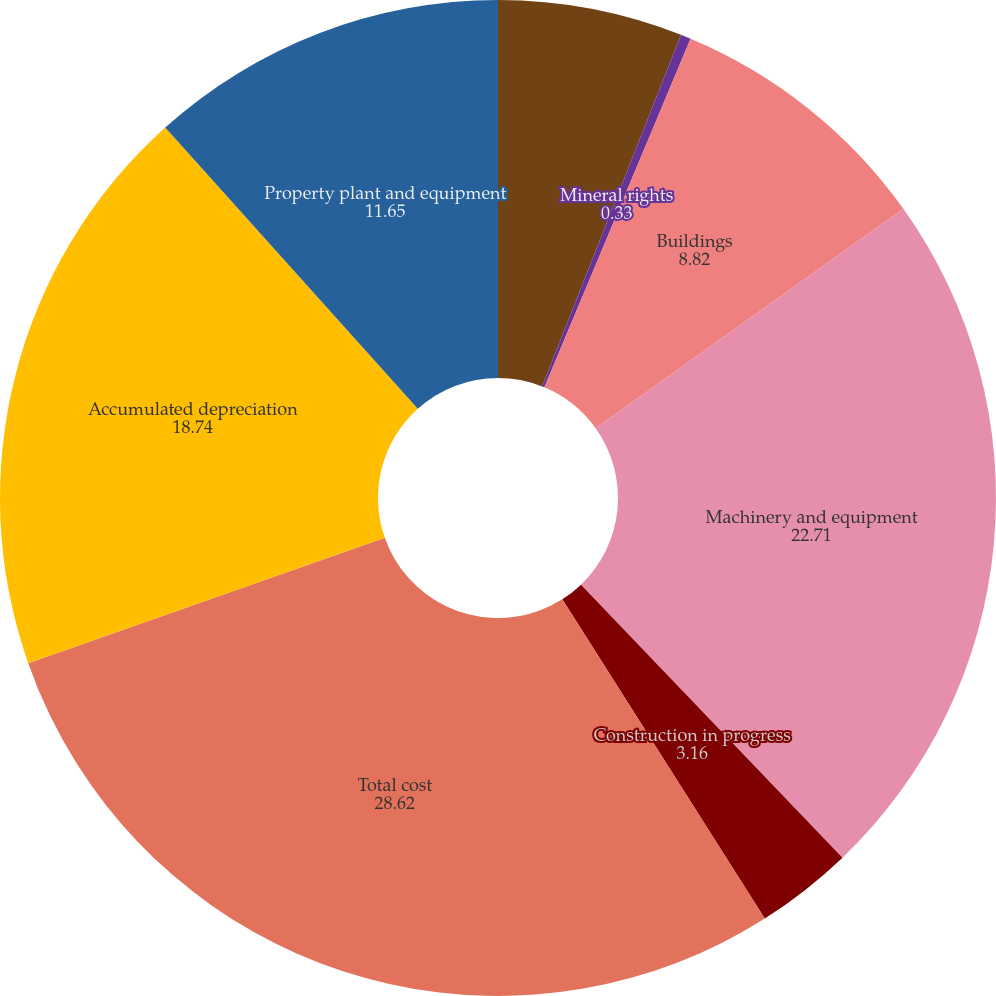<chart> <loc_0><loc_0><loc_500><loc_500><pie_chart><fcel>Land and land improvements<fcel>Mineral rights<fcel>Buildings<fcel>Machinery and equipment<fcel>Construction in progress<fcel>Total cost<fcel>Accumulated depreciation<fcel>Property plant and equipment<nl><fcel>5.99%<fcel>0.33%<fcel>8.82%<fcel>22.71%<fcel>3.16%<fcel>28.62%<fcel>18.74%<fcel>11.65%<nl></chart> 